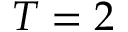Convert formula to latex. <formula><loc_0><loc_0><loc_500><loc_500>T = 2</formula> 